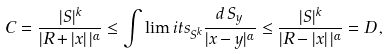<formula> <loc_0><loc_0><loc_500><loc_500>C = \frac { | S | ^ { k } } { | R + | x | \, | ^ { \alpha } } \leq \int \lim i t s _ { S ^ { k } } \frac { d \, S _ { y } } { | x - y | ^ { \alpha } } \leq \frac { | S | ^ { k } } { | R - | x | \, | ^ { \alpha } } = D \, ,</formula> 